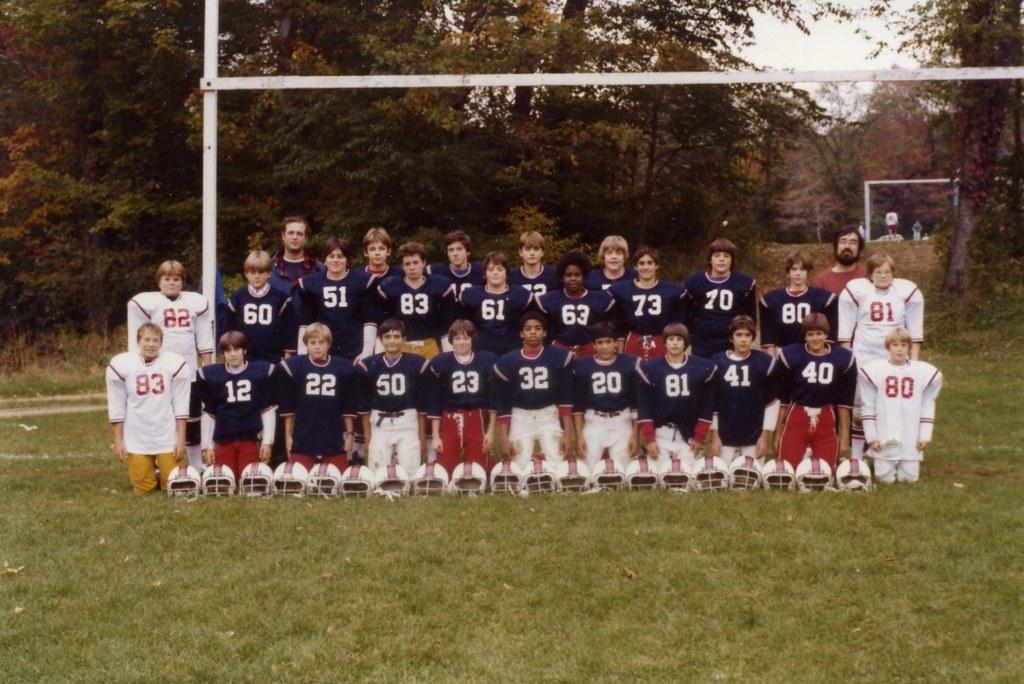Provide a one-sentence caption for the provided image. The boy wearing the number 83 poses with his football team. 